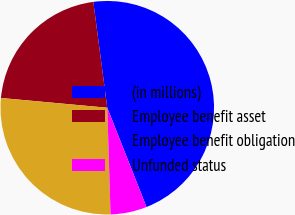Convert chart to OTSL. <chart><loc_0><loc_0><loc_500><loc_500><pie_chart><fcel>(in millions)<fcel>Employee benefit asset<fcel>Employee benefit obligation<fcel>Unfunded status<nl><fcel>46.1%<fcel>21.46%<fcel>26.95%<fcel>5.5%<nl></chart> 